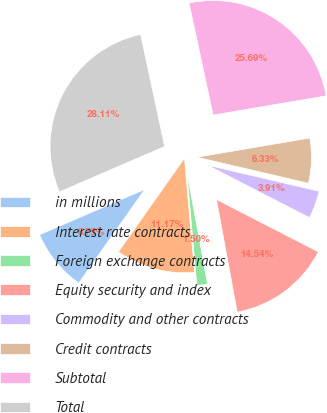Convert chart to OTSL. <chart><loc_0><loc_0><loc_500><loc_500><pie_chart><fcel>in millions<fcel>Interest rate contracts<fcel>Foreign exchange contracts<fcel>Equity security and index<fcel>Commodity and other contracts<fcel>Credit contracts<fcel>Subtotal<fcel>Total<nl><fcel>8.75%<fcel>11.17%<fcel>1.5%<fcel>14.54%<fcel>3.91%<fcel>6.33%<fcel>25.69%<fcel>28.11%<nl></chart> 